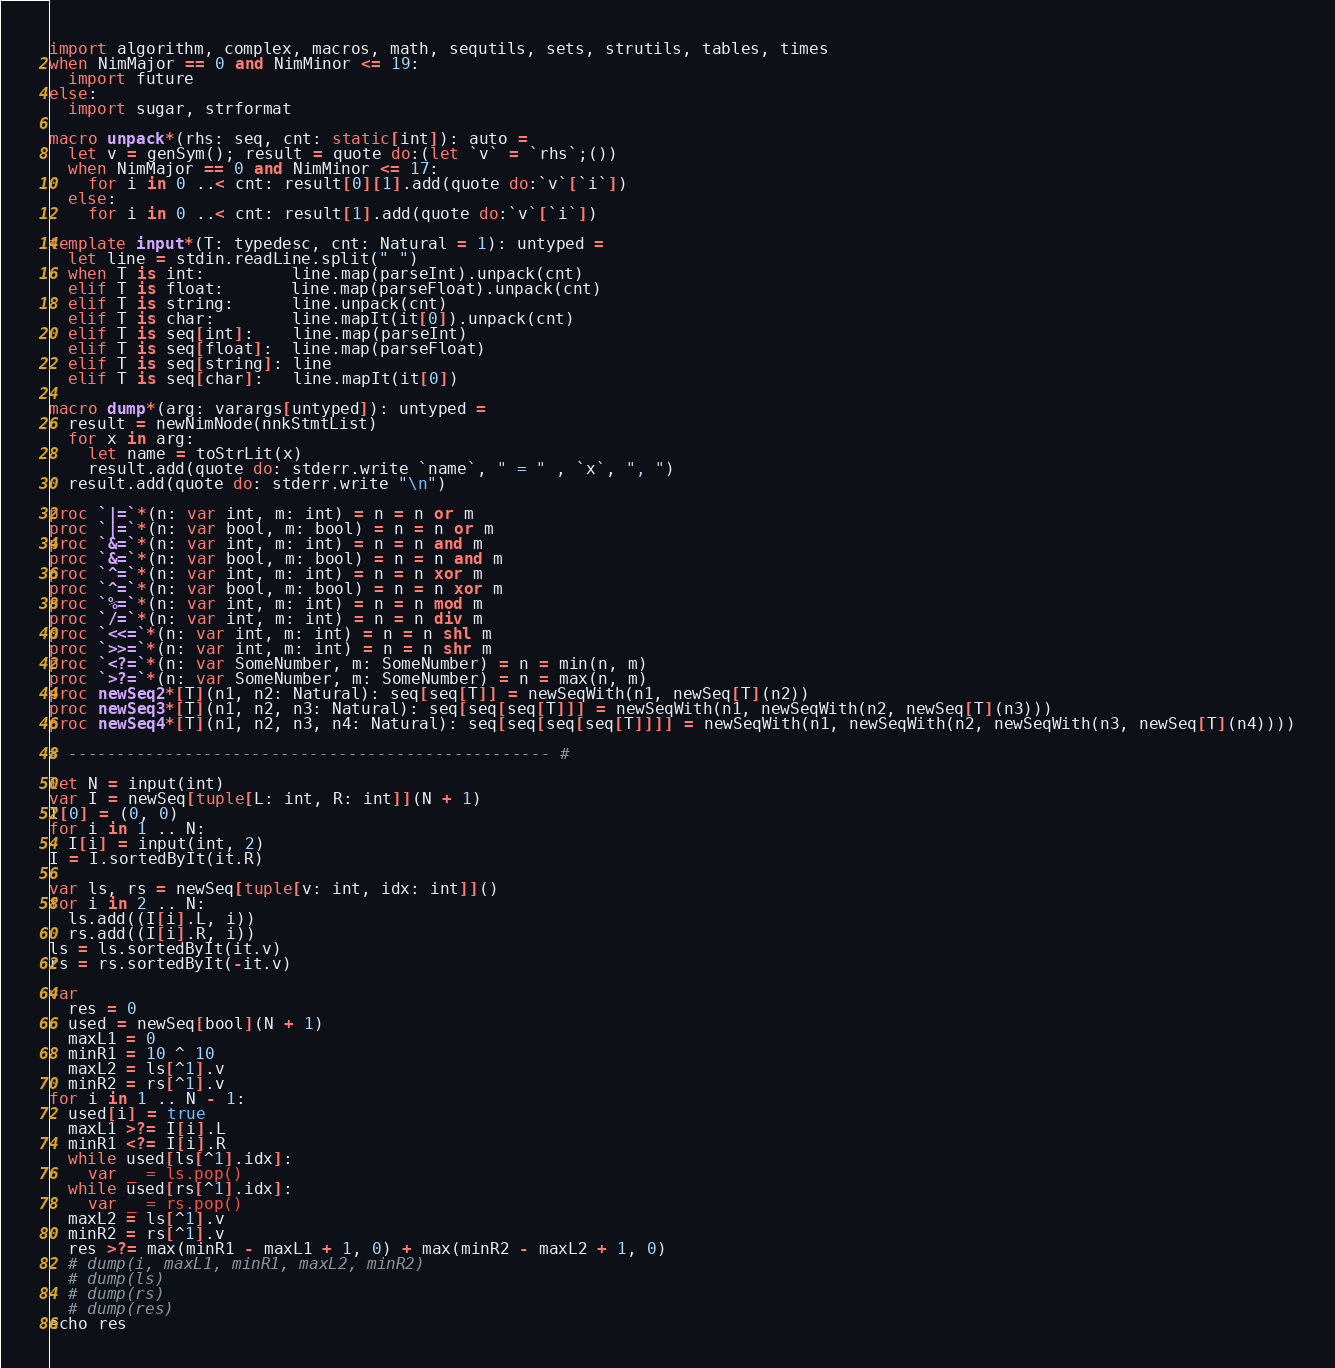<code> <loc_0><loc_0><loc_500><loc_500><_Nim_>import algorithm, complex, macros, math, sequtils, sets, strutils, tables, times
when NimMajor == 0 and NimMinor <= 19:
  import future
else:
  import sugar, strformat

macro unpack*(rhs: seq, cnt: static[int]): auto =
  let v = genSym(); result = quote do:(let `v` = `rhs`;())
  when NimMajor == 0 and NimMinor <= 17:
    for i in 0 ..< cnt: result[0][1].add(quote do:`v`[`i`])
  else:
    for i in 0 ..< cnt: result[1].add(quote do:`v`[`i`])

template input*(T: typedesc, cnt: Natural = 1): untyped =
  let line = stdin.readLine.split(" ")
  when T is int:         line.map(parseInt).unpack(cnt)
  elif T is float:       line.map(parseFloat).unpack(cnt)
  elif T is string:      line.unpack(cnt)
  elif T is char:        line.mapIt(it[0]).unpack(cnt)
  elif T is seq[int]:    line.map(parseInt)
  elif T is seq[float]:  line.map(parseFloat)
  elif T is seq[string]: line
  elif T is seq[char]:   line.mapIt(it[0])

macro dump*(arg: varargs[untyped]): untyped =
  result = newNimNode(nnkStmtList)
  for x in arg:
    let name = toStrLit(x)
    result.add(quote do: stderr.write `name`, " = " , `x`, ", ")
  result.add(quote do: stderr.write "\n")

proc `|=`*(n: var int, m: int) = n = n or m
proc `|=`*(n: var bool, m: bool) = n = n or m
proc `&=`*(n: var int, m: int) = n = n and m
proc `&=`*(n: var bool, m: bool) = n = n and m
proc `^=`*(n: var int, m: int) = n = n xor m
proc `^=`*(n: var bool, m: bool) = n = n xor m
proc `%=`*(n: var int, m: int) = n = n mod m
proc `/=`*(n: var int, m: int) = n = n div m
proc `<<=`*(n: var int, m: int) = n = n shl m
proc `>>=`*(n: var int, m: int) = n = n shr m
proc `<?=`*(n: var SomeNumber, m: SomeNumber) = n = min(n, m)
proc `>?=`*(n: var SomeNumber, m: SomeNumber) = n = max(n, m)
proc newSeq2*[T](n1, n2: Natural): seq[seq[T]] = newSeqWith(n1, newSeq[T](n2))
proc newSeq3*[T](n1, n2, n3: Natural): seq[seq[seq[T]]] = newSeqWith(n1, newSeqWith(n2, newSeq[T](n3)))
proc newSeq4*[T](n1, n2, n3, n4: Natural): seq[seq[seq[seq[T]]]] = newSeqWith(n1, newSeqWith(n2, newSeqWith(n3, newSeq[T](n4))))

# -------------------------------------------------- #

let N = input(int)
var I = newSeq[tuple[L: int, R: int]](N + 1)
I[0] = (0, 0)
for i in 1 .. N:
  I[i] = input(int, 2)
I = I.sortedByIt(it.R)

var ls, rs = newSeq[tuple[v: int, idx: int]]()
for i in 2 .. N:
  ls.add((I[i].L, i))
  rs.add((I[i].R, i))
ls = ls.sortedByIt(it.v)
rs = rs.sortedByIt(-it.v)

var
  res = 0
  used = newSeq[bool](N + 1)
  maxL1 = 0
  minR1 = 10 ^ 10
  maxL2 = ls[^1].v
  minR2 = rs[^1].v
for i in 1 .. N - 1:
  used[i] = true
  maxL1 >?= I[i].L
  minR1 <?= I[i].R
  while used[ls[^1].idx]:
    var _ = ls.pop()
  while used[rs[^1].idx]:
    var _ = rs.pop()
  maxL2 = ls[^1].v
  minR2 = rs[^1].v
  res >?= max(minR1 - maxL1 + 1, 0) + max(minR2 - maxL2 + 1, 0)
  # dump(i, maxL1, minR1, maxL2, minR2)
  # dump(ls)
  # dump(rs)
  # dump(res)
echo res</code> 